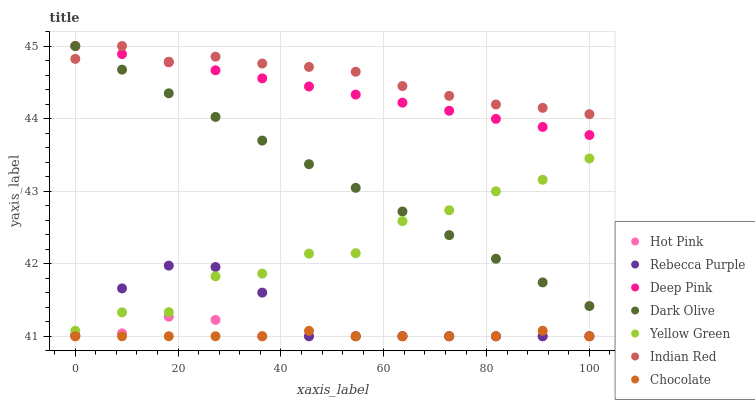Does Chocolate have the minimum area under the curve?
Answer yes or no. Yes. Does Indian Red have the maximum area under the curve?
Answer yes or no. Yes. Does Yellow Green have the minimum area under the curve?
Answer yes or no. No. Does Yellow Green have the maximum area under the curve?
Answer yes or no. No. Is Deep Pink the smoothest?
Answer yes or no. Yes. Is Yellow Green the roughest?
Answer yes or no. Yes. Is Dark Olive the smoothest?
Answer yes or no. No. Is Dark Olive the roughest?
Answer yes or no. No. Does Hot Pink have the lowest value?
Answer yes or no. Yes. Does Yellow Green have the lowest value?
Answer yes or no. No. Does Indian Red have the highest value?
Answer yes or no. Yes. Does Yellow Green have the highest value?
Answer yes or no. No. Is Hot Pink less than Yellow Green?
Answer yes or no. Yes. Is Yellow Green greater than Chocolate?
Answer yes or no. Yes. Does Dark Olive intersect Deep Pink?
Answer yes or no. Yes. Is Dark Olive less than Deep Pink?
Answer yes or no. No. Is Dark Olive greater than Deep Pink?
Answer yes or no. No. Does Hot Pink intersect Yellow Green?
Answer yes or no. No. 